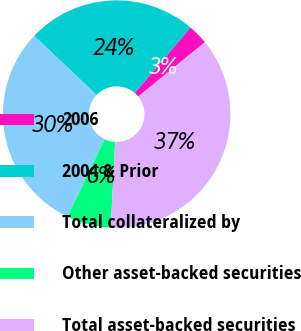Convert chart to OTSL. <chart><loc_0><loc_0><loc_500><loc_500><pie_chart><fcel>2006<fcel>2004 & Prior<fcel>Total collateralized by<fcel>Other asset-backed securities<fcel>Total asset-backed securities<nl><fcel>2.9%<fcel>24.15%<fcel>29.95%<fcel>6.28%<fcel>36.71%<nl></chart> 